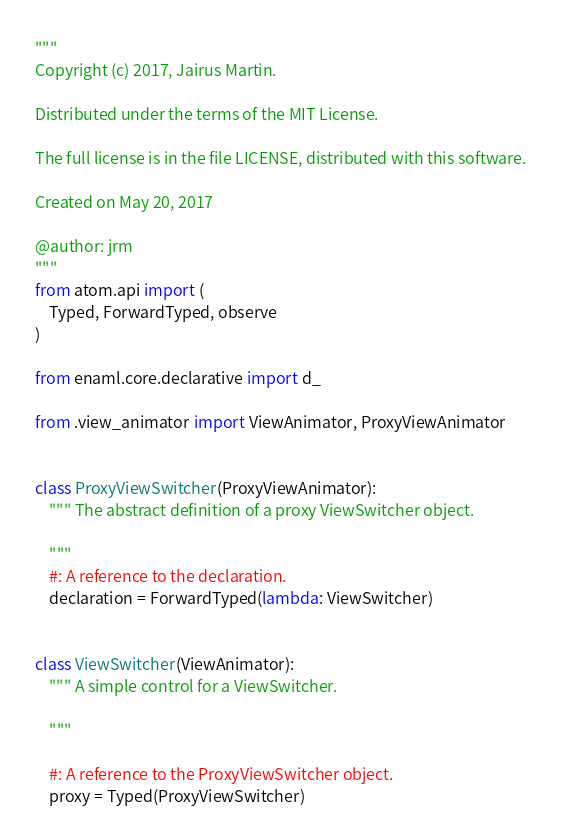<code> <loc_0><loc_0><loc_500><loc_500><_Python_>"""
Copyright (c) 2017, Jairus Martin.

Distributed under the terms of the MIT License.

The full license is in the file LICENSE, distributed with this software.

Created on May 20, 2017

@author: jrm
"""
from atom.api import (
    Typed, ForwardTyped, observe
)

from enaml.core.declarative import d_

from .view_animator import ViewAnimator, ProxyViewAnimator


class ProxyViewSwitcher(ProxyViewAnimator):
    """ The abstract definition of a proxy ViewSwitcher object.

    """
    #: A reference to the declaration.
    declaration = ForwardTyped(lambda: ViewSwitcher)


class ViewSwitcher(ViewAnimator):
    """ A simple control for a ViewSwitcher.

    """
    
    #: A reference to the ProxyViewSwitcher object.
    proxy = Typed(ProxyViewSwitcher)

</code> 